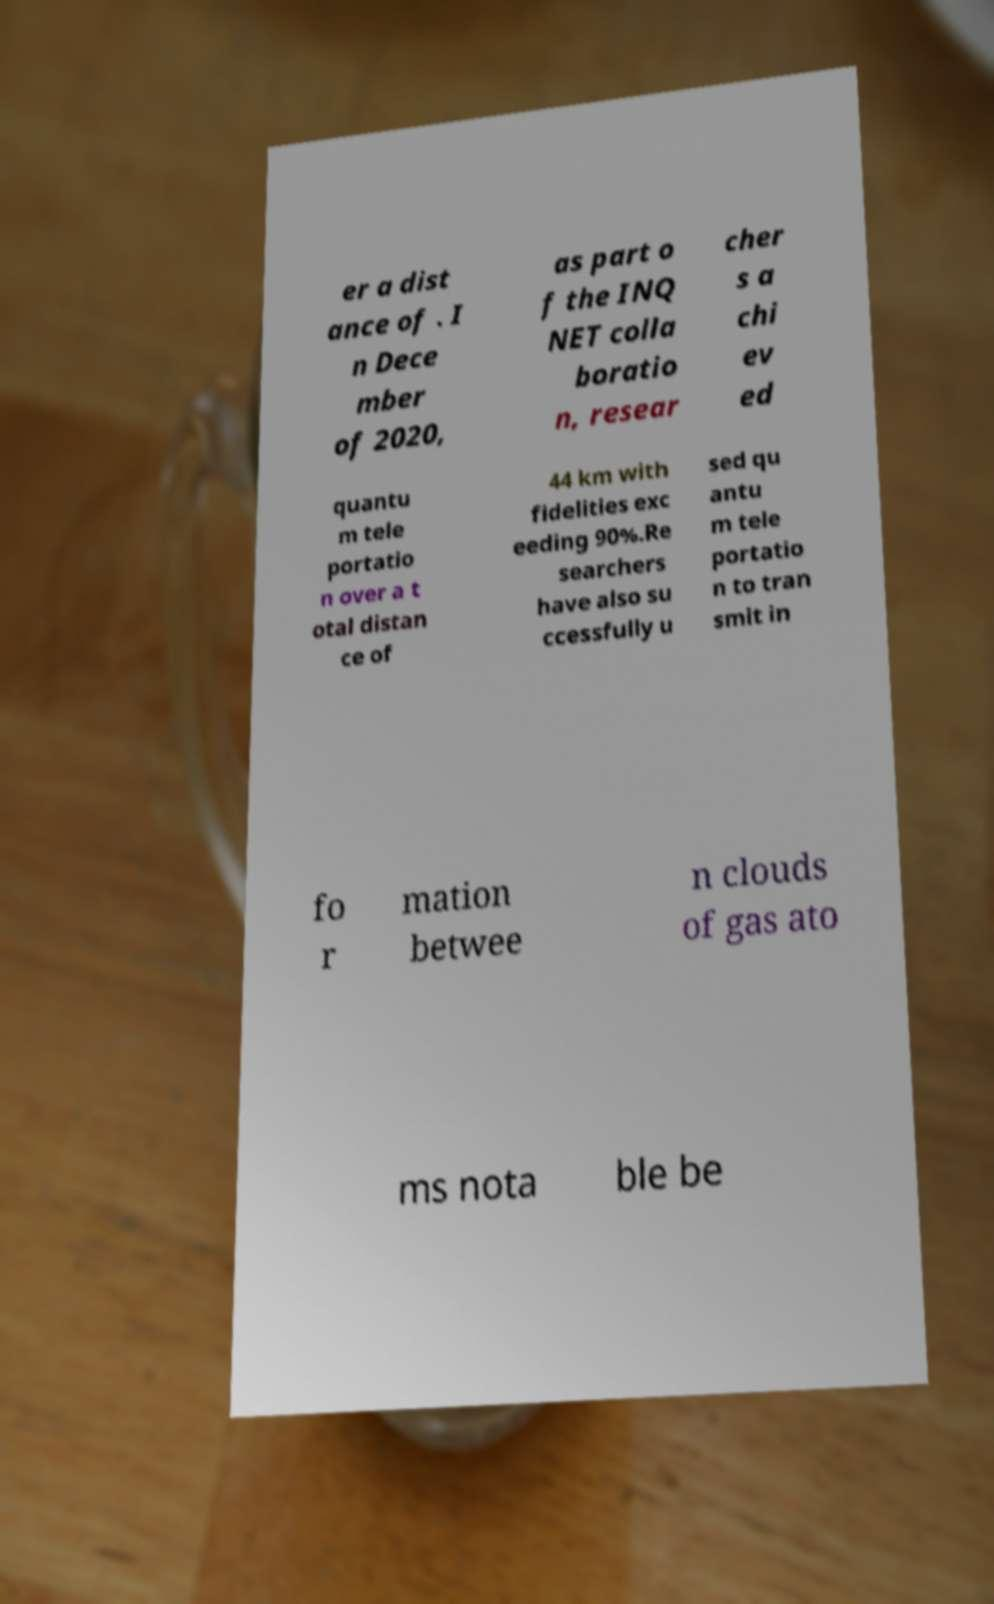What messages or text are displayed in this image? I need them in a readable, typed format. er a dist ance of . I n Dece mber of 2020, as part o f the INQ NET colla boratio n, resear cher s a chi ev ed quantu m tele portatio n over a t otal distan ce of 44 km with fidelities exc eeding 90%.Re searchers have also su ccessfully u sed qu antu m tele portatio n to tran smit in fo r mation betwee n clouds of gas ato ms nota ble be 